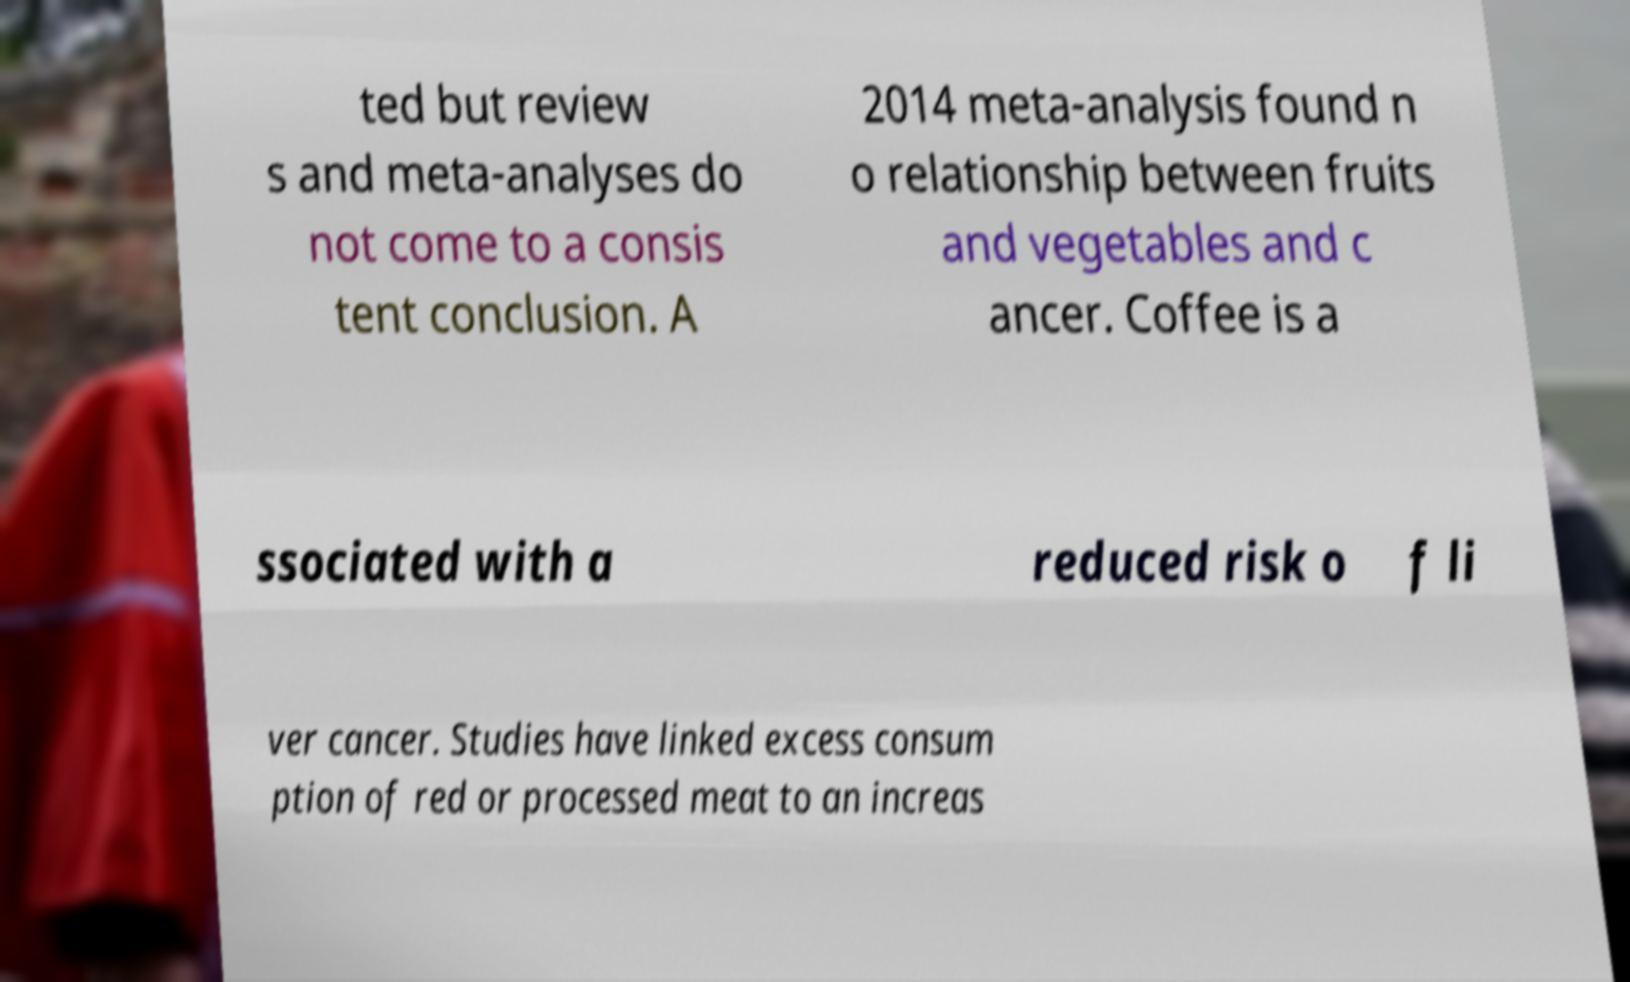Could you extract and type out the text from this image? ted but review s and meta-analyses do not come to a consis tent conclusion. A 2014 meta-analysis found n o relationship between fruits and vegetables and c ancer. Coffee is a ssociated with a reduced risk o f li ver cancer. Studies have linked excess consum ption of red or processed meat to an increas 